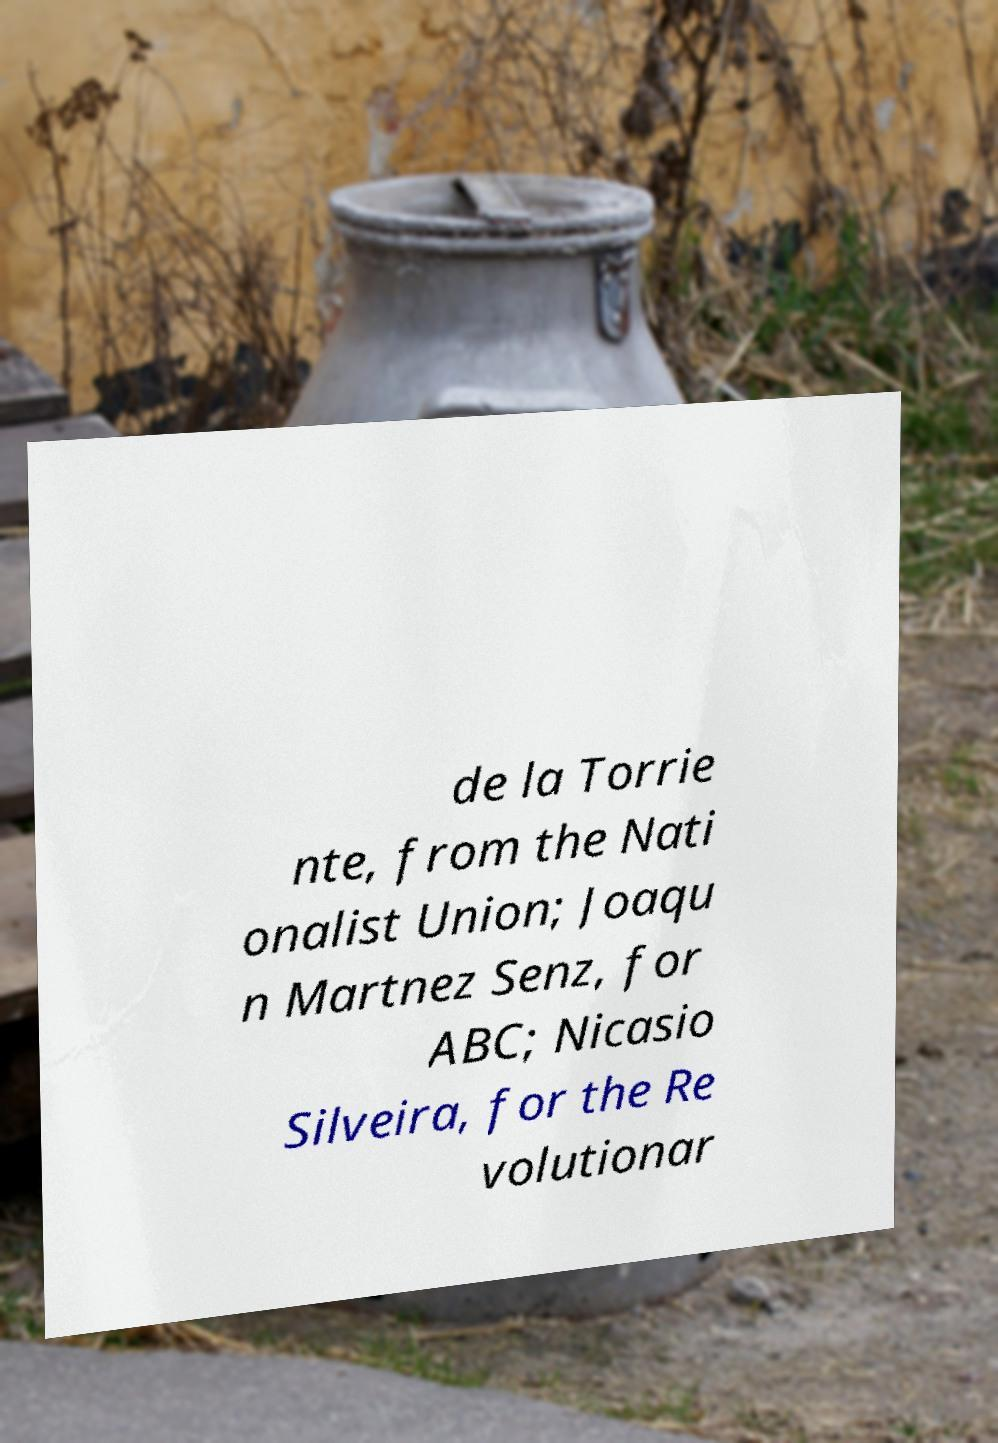For documentation purposes, I need the text within this image transcribed. Could you provide that? de la Torrie nte, from the Nati onalist Union; Joaqu n Martnez Senz, for ABC; Nicasio Silveira, for the Re volutionar 